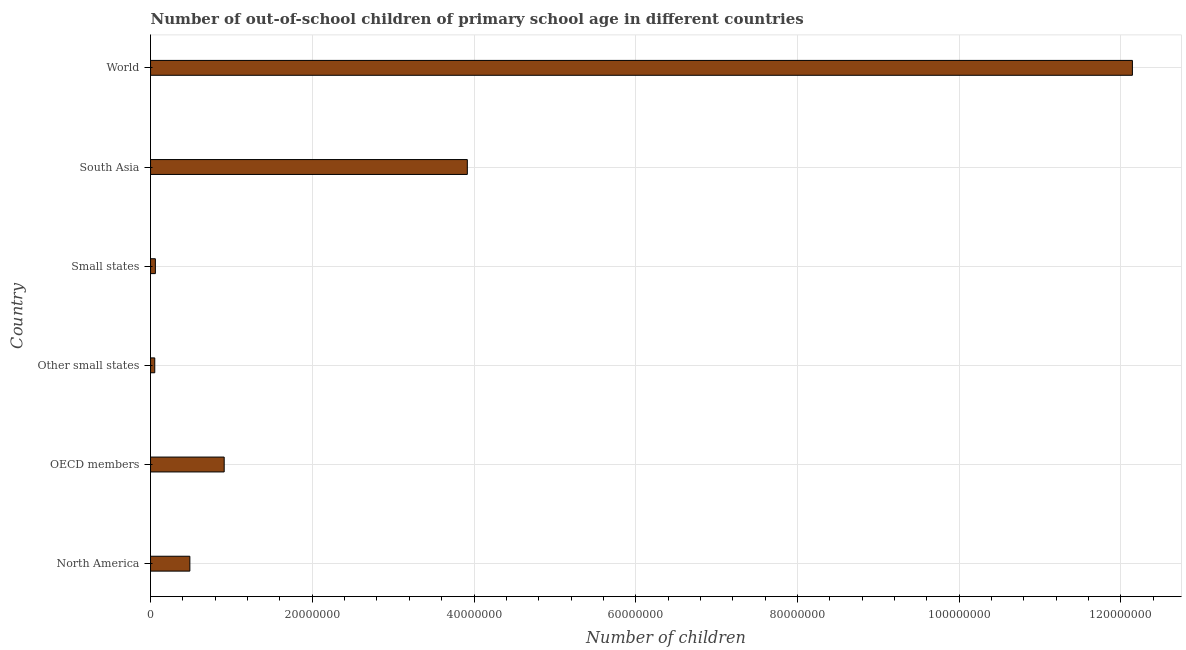Does the graph contain any zero values?
Offer a very short reply. No. Does the graph contain grids?
Ensure brevity in your answer.  Yes. What is the title of the graph?
Make the answer very short. Number of out-of-school children of primary school age in different countries. What is the label or title of the X-axis?
Offer a terse response. Number of children. What is the label or title of the Y-axis?
Give a very brief answer. Country. What is the number of out-of-school children in World?
Provide a succinct answer. 1.21e+08. Across all countries, what is the maximum number of out-of-school children?
Make the answer very short. 1.21e+08. Across all countries, what is the minimum number of out-of-school children?
Provide a short and direct response. 5.23e+05. In which country was the number of out-of-school children maximum?
Your answer should be compact. World. In which country was the number of out-of-school children minimum?
Provide a short and direct response. Other small states. What is the sum of the number of out-of-school children?
Give a very brief answer. 1.76e+08. What is the difference between the number of out-of-school children in North America and Small states?
Your answer should be very brief. 4.26e+06. What is the average number of out-of-school children per country?
Ensure brevity in your answer.  2.93e+07. What is the median number of out-of-school children?
Your answer should be compact. 6.98e+06. In how many countries, is the number of out-of-school children greater than 36000000 ?
Give a very brief answer. 2. What is the ratio of the number of out-of-school children in Other small states to that in South Asia?
Provide a succinct answer. 0.01. Is the number of out-of-school children in OECD members less than that in Small states?
Offer a very short reply. No. What is the difference between the highest and the second highest number of out-of-school children?
Make the answer very short. 8.22e+07. What is the difference between the highest and the lowest number of out-of-school children?
Provide a succinct answer. 1.21e+08. In how many countries, is the number of out-of-school children greater than the average number of out-of-school children taken over all countries?
Your answer should be very brief. 2. How many bars are there?
Provide a short and direct response. 6. How many countries are there in the graph?
Provide a succinct answer. 6. Are the values on the major ticks of X-axis written in scientific E-notation?
Your response must be concise. No. What is the Number of children in North America?
Give a very brief answer. 4.86e+06. What is the Number of children in OECD members?
Offer a terse response. 9.11e+06. What is the Number of children of Other small states?
Your answer should be very brief. 5.23e+05. What is the Number of children of Small states?
Provide a short and direct response. 5.99e+05. What is the Number of children in South Asia?
Ensure brevity in your answer.  3.92e+07. What is the Number of children of World?
Your response must be concise. 1.21e+08. What is the difference between the Number of children in North America and OECD members?
Offer a terse response. -4.25e+06. What is the difference between the Number of children in North America and Other small states?
Offer a terse response. 4.34e+06. What is the difference between the Number of children in North America and Small states?
Your response must be concise. 4.26e+06. What is the difference between the Number of children in North America and South Asia?
Your answer should be compact. -3.43e+07. What is the difference between the Number of children in North America and World?
Offer a terse response. -1.17e+08. What is the difference between the Number of children in OECD members and Other small states?
Your answer should be very brief. 8.58e+06. What is the difference between the Number of children in OECD members and Small states?
Your answer should be very brief. 8.51e+06. What is the difference between the Number of children in OECD members and South Asia?
Your answer should be very brief. -3.01e+07. What is the difference between the Number of children in OECD members and World?
Your answer should be compact. -1.12e+08. What is the difference between the Number of children in Other small states and Small states?
Keep it short and to the point. -7.59e+04. What is the difference between the Number of children in Other small states and South Asia?
Your answer should be compact. -3.86e+07. What is the difference between the Number of children in Other small states and World?
Your response must be concise. -1.21e+08. What is the difference between the Number of children in Small states and South Asia?
Keep it short and to the point. -3.86e+07. What is the difference between the Number of children in Small states and World?
Give a very brief answer. -1.21e+08. What is the difference between the Number of children in South Asia and World?
Your response must be concise. -8.22e+07. What is the ratio of the Number of children in North America to that in OECD members?
Your answer should be compact. 0.53. What is the ratio of the Number of children in North America to that in Other small states?
Keep it short and to the point. 9.3. What is the ratio of the Number of children in North America to that in Small states?
Offer a very short reply. 8.12. What is the ratio of the Number of children in North America to that in South Asia?
Your answer should be very brief. 0.12. What is the ratio of the Number of children in OECD members to that in Other small states?
Provide a short and direct response. 17.42. What is the ratio of the Number of children in OECD members to that in Small states?
Keep it short and to the point. 15.21. What is the ratio of the Number of children in OECD members to that in South Asia?
Your answer should be compact. 0.23. What is the ratio of the Number of children in OECD members to that in World?
Offer a terse response. 0.07. What is the ratio of the Number of children in Other small states to that in Small states?
Offer a terse response. 0.87. What is the ratio of the Number of children in Other small states to that in South Asia?
Ensure brevity in your answer.  0.01. What is the ratio of the Number of children in Other small states to that in World?
Provide a short and direct response. 0. What is the ratio of the Number of children in Small states to that in South Asia?
Offer a very short reply. 0.01. What is the ratio of the Number of children in Small states to that in World?
Make the answer very short. 0.01. What is the ratio of the Number of children in South Asia to that in World?
Provide a short and direct response. 0.32. 